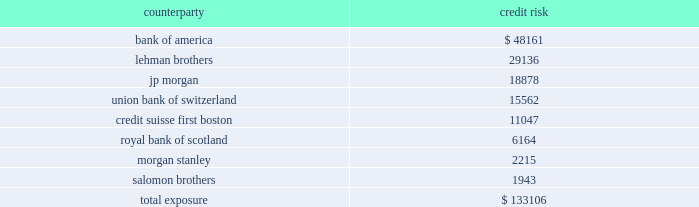Mortgage banking activities the company enters into commitments to originate loans whereby the interest rate on the loan is determined prior to funding .
These commitments are referred to as interest rate lock commitments ( 201cirlcs 201d ) .
Irlcs on loans that the company intends to sell are considered to be derivatives and are , therefore , recorded at fair value with changes in fair value recorded in earnings .
For purposes of determining fair value , the company estimates the fair value of an irlc based on the estimated fair value of the underlying mortgage loan and the probability that the mortgage loan will fund within the terms of the irlc .
The fair value excludes the market value associated with the anticipated sale of servicing rights related to each loan commitment .
The fair value of these irlcs was a $ 0.06 million and a $ 0.02 million liability at december 31 , 2007 and 2006 , respectively .
The company also designates fair value relationships of closed loans held-for-sale against a combination of mortgage forwards and short treasury positions .
Short treasury relationships are economic hedges , rather than fair value or cash flow hedges .
Short treasury positions are marked-to-market , but do not receive hedge accounting treatment under sfas no .
133 , as amended .
The mark-to-market of the mortgage forwards is included in the net change of the irlcs and the related hedging instruments .
The fair value of the mark-to-market on closed loans was a $ 1.2 thousand and $ 1.7 million asset at december 31 , 2007 and 2006 , respectively .
Irlcs , as well as closed loans held-for-sale , expose the company to interest rate risk .
The company manages this risk by selling mortgages or mortgage-backed securities on a forward basis referred to as forward sale agreements .
Changes in the fair value of these derivatives are included as gain ( loss ) on loans and securities , net in the consolidated statement of income ( loss ) .
The net change in irlcs , closed loans , mortgage forwards and the short treasury positions generated a net loss of $ 2.4 million in 2007 , a net gain of $ 1.6 million in 2006 and a net loss of $ 0.4 million in 2005 .
Credit risk credit risk is managed by limiting activity to approved counterparties and setting aggregate exposure limits for each approved counterparty .
The credit risk , or maximum exposure , which results from interest rate swaps and purchased interest rate options is represented by the fair value of contracts that have unrealized gains at the reporting date .
Conversely , we have $ 197.5 million of derivative contracts with unrealized losses at december 31 , 2007 .
The company pledged approximately $ 87.4 million of its mortgage-backed securities as collateral of derivative contracts .
While the company does not expect that any counterparty will fail to perform , the table shows the maximum exposure associated with each counterparty to interest rate swaps and purchased interest rate options at december 31 , 2007 ( dollars in thousands ) : counterparty credit .

What was the ratio of the derivative contracts at december 31 , 2007 to mortgage-backed securities as collateral of derivative contracts .? 
Rationale: as of december 2007 there was $ 2.26 of derivatives for each $ 1 of collateral in mortgage backed securities
Computations: (197.5 / 87.4)
Answer: 2.25973. 